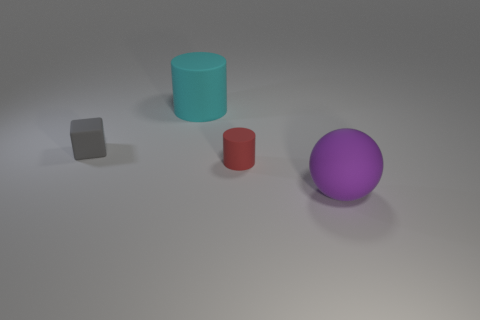Subtract all red cylinders. How many cylinders are left? 1 Add 3 large cyan objects. How many objects exist? 7 Subtract all balls. How many objects are left? 3 Subtract 1 blocks. How many blocks are left? 0 Subtract 0 purple cubes. How many objects are left? 4 Subtract all purple cylinders. Subtract all gray spheres. How many cylinders are left? 2 Subtract all red spheres. How many brown cylinders are left? 0 Subtract all large rubber cylinders. Subtract all large purple matte things. How many objects are left? 2 Add 1 small gray objects. How many small gray objects are left? 2 Add 3 big matte cylinders. How many big matte cylinders exist? 4 